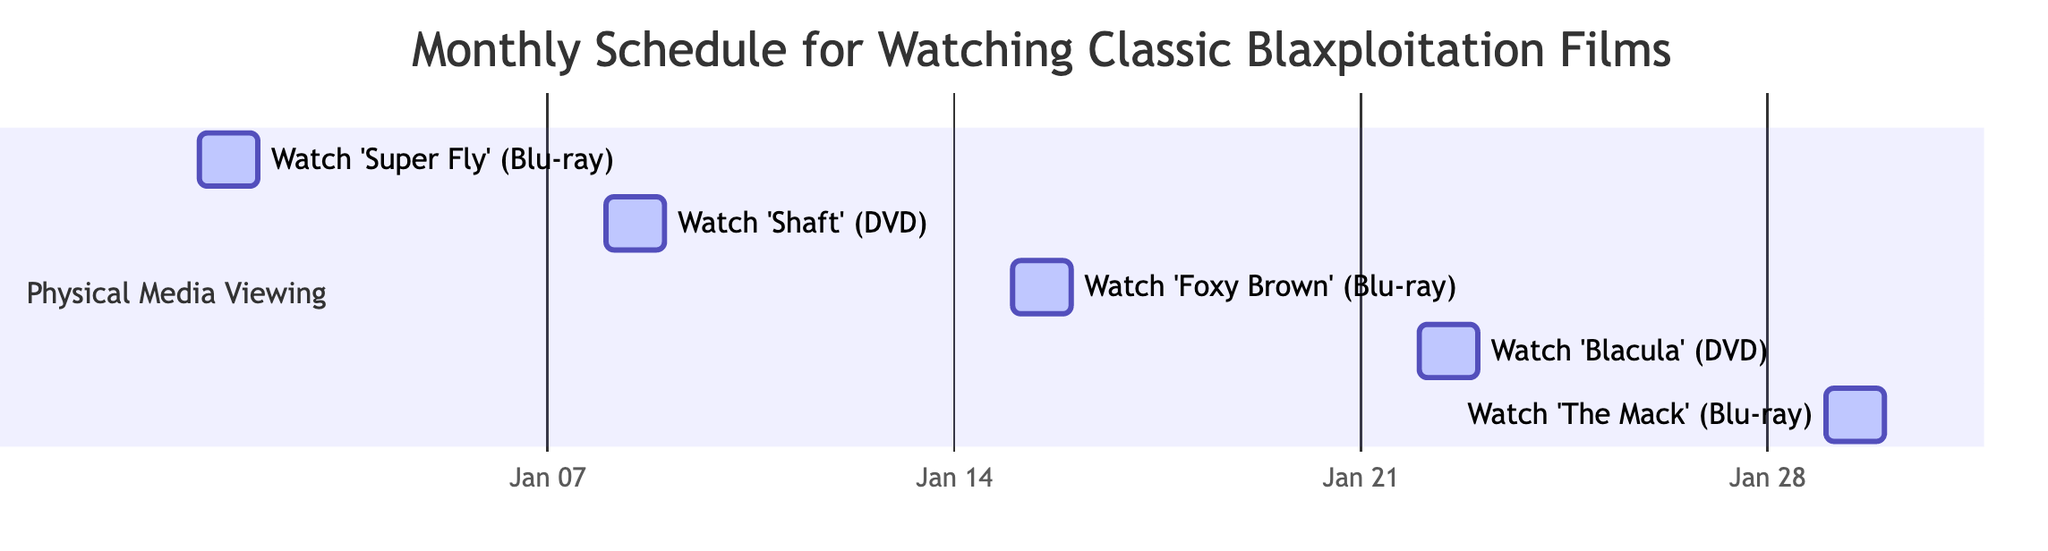What is the duration for each film on the schedule? Each film on the schedule has a duration of 1 day. This can be confirmed by looking at the ‘duration’ attribute in each task entry.
Answer: 1 day How many films are scheduled to be watched in January 2024? The diagram includes five tasks for films scheduled within January 2024: 'Super Fly', 'Shaft', 'Foxy Brown', 'Blacula', and 'The Mack'. Therefore, there are five films scheduled.
Answer: 5 What type of media is 'Blacula' being watched on? The media type for 'Blacula' can be found in its respective task entry, which states it is being watched on DVD.
Answer: DVD Which film is scheduled to be watched last in January? By examining the start dates of the tasks listed, 'The Mack' is the last film scheduled to be watched on January 29, 2024.
Answer: The Mack What is the start date for watching 'Foxy Brown'? The start date for 'Foxy Brown' is given as January 15, 2024, in the task entry corresponding to that film.
Answer: January 15, 2024 How many Blu-ray films are on the schedule? Looking at the tasks, there are three films being watched on Blu-ray: 'Super Fly', 'Foxy Brown', and 'The Mack'. By counting these entries, we determine there are three Blu-ray films.
Answer: 3 Is 'Shaft' scheduled before or after 'Blacula'? Comparing the start dates, 'Shaft' is scheduled for January 8 and 'Blacula' for January 22. Therefore, 'Shaft' is scheduled before 'Blacula'.
Answer: Before What is the media format for the first film on the schedule? The first film on the schedule is 'Super Fly', which is indicated to be watched on Blu-ray in the diagram.
Answer: Blu-ray 